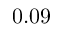Convert formula to latex. <formula><loc_0><loc_0><loc_500><loc_500>0 . 0 9</formula> 